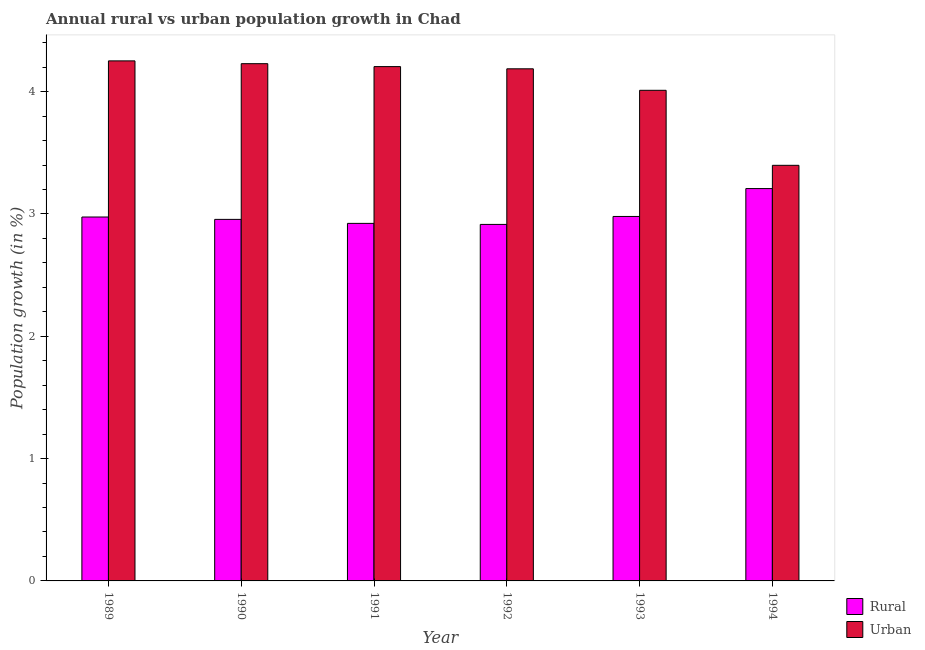How many different coloured bars are there?
Offer a very short reply. 2. Are the number of bars per tick equal to the number of legend labels?
Your answer should be very brief. Yes. Are the number of bars on each tick of the X-axis equal?
Your answer should be very brief. Yes. In how many cases, is the number of bars for a given year not equal to the number of legend labels?
Your response must be concise. 0. What is the rural population growth in 1992?
Your answer should be compact. 2.91. Across all years, what is the maximum urban population growth?
Offer a very short reply. 4.25. Across all years, what is the minimum urban population growth?
Give a very brief answer. 3.4. In which year was the rural population growth maximum?
Offer a terse response. 1994. In which year was the urban population growth minimum?
Provide a succinct answer. 1994. What is the total rural population growth in the graph?
Provide a short and direct response. 17.96. What is the difference between the rural population growth in 1990 and that in 1992?
Your answer should be very brief. 0.04. What is the difference between the rural population growth in 1994 and the urban population growth in 1992?
Make the answer very short. 0.29. What is the average rural population growth per year?
Your answer should be very brief. 2.99. What is the ratio of the urban population growth in 1989 to that in 1990?
Your answer should be very brief. 1.01. Is the rural population growth in 1990 less than that in 1994?
Your answer should be compact. Yes. What is the difference between the highest and the second highest rural population growth?
Make the answer very short. 0.23. What is the difference between the highest and the lowest urban population growth?
Keep it short and to the point. 0.85. Is the sum of the rural population growth in 1991 and 1994 greater than the maximum urban population growth across all years?
Offer a terse response. Yes. What does the 2nd bar from the left in 1994 represents?
Your answer should be very brief. Urban . What does the 1st bar from the right in 1993 represents?
Keep it short and to the point. Urban . How many bars are there?
Provide a short and direct response. 12. How many years are there in the graph?
Make the answer very short. 6. What is the difference between two consecutive major ticks on the Y-axis?
Offer a very short reply. 1. Does the graph contain any zero values?
Offer a very short reply. No. Does the graph contain grids?
Offer a very short reply. No. What is the title of the graph?
Keep it short and to the point. Annual rural vs urban population growth in Chad. Does "IMF concessional" appear as one of the legend labels in the graph?
Your response must be concise. No. What is the label or title of the Y-axis?
Keep it short and to the point. Population growth (in %). What is the Population growth (in %) of Rural in 1989?
Give a very brief answer. 2.98. What is the Population growth (in %) in Urban  in 1989?
Your answer should be compact. 4.25. What is the Population growth (in %) of Rural in 1990?
Make the answer very short. 2.96. What is the Population growth (in %) of Urban  in 1990?
Provide a succinct answer. 4.23. What is the Population growth (in %) of Rural in 1991?
Provide a short and direct response. 2.92. What is the Population growth (in %) in Urban  in 1991?
Give a very brief answer. 4.2. What is the Population growth (in %) in Rural in 1992?
Your answer should be compact. 2.91. What is the Population growth (in %) of Urban  in 1992?
Your response must be concise. 4.19. What is the Population growth (in %) in Rural in 1993?
Your answer should be very brief. 2.98. What is the Population growth (in %) of Urban  in 1993?
Provide a short and direct response. 4.01. What is the Population growth (in %) in Rural in 1994?
Make the answer very short. 3.21. What is the Population growth (in %) in Urban  in 1994?
Your answer should be very brief. 3.4. Across all years, what is the maximum Population growth (in %) in Rural?
Offer a very short reply. 3.21. Across all years, what is the maximum Population growth (in %) of Urban ?
Your answer should be very brief. 4.25. Across all years, what is the minimum Population growth (in %) of Rural?
Offer a terse response. 2.91. Across all years, what is the minimum Population growth (in %) in Urban ?
Your answer should be compact. 3.4. What is the total Population growth (in %) in Rural in the graph?
Your answer should be very brief. 17.96. What is the total Population growth (in %) in Urban  in the graph?
Keep it short and to the point. 24.28. What is the difference between the Population growth (in %) of Rural in 1989 and that in 1990?
Provide a succinct answer. 0.02. What is the difference between the Population growth (in %) in Urban  in 1989 and that in 1990?
Provide a succinct answer. 0.02. What is the difference between the Population growth (in %) of Rural in 1989 and that in 1991?
Offer a terse response. 0.05. What is the difference between the Population growth (in %) in Urban  in 1989 and that in 1991?
Provide a short and direct response. 0.05. What is the difference between the Population growth (in %) of Rural in 1989 and that in 1992?
Offer a very short reply. 0.06. What is the difference between the Population growth (in %) of Urban  in 1989 and that in 1992?
Keep it short and to the point. 0.06. What is the difference between the Population growth (in %) of Rural in 1989 and that in 1993?
Make the answer very short. -0. What is the difference between the Population growth (in %) of Urban  in 1989 and that in 1993?
Offer a terse response. 0.24. What is the difference between the Population growth (in %) in Rural in 1989 and that in 1994?
Keep it short and to the point. -0.23. What is the difference between the Population growth (in %) in Urban  in 1989 and that in 1994?
Give a very brief answer. 0.85. What is the difference between the Population growth (in %) in Rural in 1990 and that in 1991?
Provide a succinct answer. 0.03. What is the difference between the Population growth (in %) of Urban  in 1990 and that in 1991?
Give a very brief answer. 0.02. What is the difference between the Population growth (in %) in Rural in 1990 and that in 1992?
Provide a short and direct response. 0.04. What is the difference between the Population growth (in %) of Urban  in 1990 and that in 1992?
Your response must be concise. 0.04. What is the difference between the Population growth (in %) in Rural in 1990 and that in 1993?
Offer a terse response. -0.02. What is the difference between the Population growth (in %) in Urban  in 1990 and that in 1993?
Offer a very short reply. 0.22. What is the difference between the Population growth (in %) of Rural in 1990 and that in 1994?
Provide a short and direct response. -0.25. What is the difference between the Population growth (in %) in Urban  in 1990 and that in 1994?
Offer a terse response. 0.83. What is the difference between the Population growth (in %) in Rural in 1991 and that in 1992?
Offer a terse response. 0.01. What is the difference between the Population growth (in %) of Urban  in 1991 and that in 1992?
Provide a succinct answer. 0.02. What is the difference between the Population growth (in %) of Rural in 1991 and that in 1993?
Give a very brief answer. -0.06. What is the difference between the Population growth (in %) of Urban  in 1991 and that in 1993?
Your response must be concise. 0.19. What is the difference between the Population growth (in %) of Rural in 1991 and that in 1994?
Your response must be concise. -0.28. What is the difference between the Population growth (in %) of Urban  in 1991 and that in 1994?
Provide a short and direct response. 0.81. What is the difference between the Population growth (in %) in Rural in 1992 and that in 1993?
Provide a succinct answer. -0.07. What is the difference between the Population growth (in %) of Urban  in 1992 and that in 1993?
Offer a very short reply. 0.18. What is the difference between the Population growth (in %) of Rural in 1992 and that in 1994?
Make the answer very short. -0.29. What is the difference between the Population growth (in %) of Urban  in 1992 and that in 1994?
Make the answer very short. 0.79. What is the difference between the Population growth (in %) in Rural in 1993 and that in 1994?
Your response must be concise. -0.23. What is the difference between the Population growth (in %) of Urban  in 1993 and that in 1994?
Keep it short and to the point. 0.61. What is the difference between the Population growth (in %) in Rural in 1989 and the Population growth (in %) in Urban  in 1990?
Keep it short and to the point. -1.25. What is the difference between the Population growth (in %) in Rural in 1989 and the Population growth (in %) in Urban  in 1991?
Keep it short and to the point. -1.23. What is the difference between the Population growth (in %) of Rural in 1989 and the Population growth (in %) of Urban  in 1992?
Your response must be concise. -1.21. What is the difference between the Population growth (in %) in Rural in 1989 and the Population growth (in %) in Urban  in 1993?
Offer a very short reply. -1.04. What is the difference between the Population growth (in %) in Rural in 1989 and the Population growth (in %) in Urban  in 1994?
Your answer should be compact. -0.42. What is the difference between the Population growth (in %) of Rural in 1990 and the Population growth (in %) of Urban  in 1991?
Offer a terse response. -1.25. What is the difference between the Population growth (in %) in Rural in 1990 and the Population growth (in %) in Urban  in 1992?
Provide a short and direct response. -1.23. What is the difference between the Population growth (in %) of Rural in 1990 and the Population growth (in %) of Urban  in 1993?
Offer a terse response. -1.06. What is the difference between the Population growth (in %) of Rural in 1990 and the Population growth (in %) of Urban  in 1994?
Provide a short and direct response. -0.44. What is the difference between the Population growth (in %) of Rural in 1991 and the Population growth (in %) of Urban  in 1992?
Give a very brief answer. -1.26. What is the difference between the Population growth (in %) of Rural in 1991 and the Population growth (in %) of Urban  in 1993?
Provide a succinct answer. -1.09. What is the difference between the Population growth (in %) of Rural in 1991 and the Population growth (in %) of Urban  in 1994?
Keep it short and to the point. -0.47. What is the difference between the Population growth (in %) of Rural in 1992 and the Population growth (in %) of Urban  in 1993?
Ensure brevity in your answer.  -1.1. What is the difference between the Population growth (in %) in Rural in 1992 and the Population growth (in %) in Urban  in 1994?
Ensure brevity in your answer.  -0.48. What is the difference between the Population growth (in %) of Rural in 1993 and the Population growth (in %) of Urban  in 1994?
Provide a short and direct response. -0.42. What is the average Population growth (in %) in Rural per year?
Give a very brief answer. 2.99. What is the average Population growth (in %) of Urban  per year?
Offer a terse response. 4.05. In the year 1989, what is the difference between the Population growth (in %) in Rural and Population growth (in %) in Urban ?
Offer a very short reply. -1.28. In the year 1990, what is the difference between the Population growth (in %) of Rural and Population growth (in %) of Urban ?
Provide a succinct answer. -1.27. In the year 1991, what is the difference between the Population growth (in %) of Rural and Population growth (in %) of Urban ?
Offer a very short reply. -1.28. In the year 1992, what is the difference between the Population growth (in %) of Rural and Population growth (in %) of Urban ?
Your answer should be very brief. -1.27. In the year 1993, what is the difference between the Population growth (in %) of Rural and Population growth (in %) of Urban ?
Give a very brief answer. -1.03. In the year 1994, what is the difference between the Population growth (in %) in Rural and Population growth (in %) in Urban ?
Your answer should be compact. -0.19. What is the ratio of the Population growth (in %) of Rural in 1989 to that in 1990?
Offer a terse response. 1.01. What is the ratio of the Population growth (in %) of Urban  in 1989 to that in 1990?
Make the answer very short. 1.01. What is the ratio of the Population growth (in %) in Rural in 1989 to that in 1991?
Offer a very short reply. 1.02. What is the ratio of the Population growth (in %) of Urban  in 1989 to that in 1991?
Your answer should be compact. 1.01. What is the ratio of the Population growth (in %) of Rural in 1989 to that in 1992?
Ensure brevity in your answer.  1.02. What is the ratio of the Population growth (in %) of Urban  in 1989 to that in 1992?
Give a very brief answer. 1.02. What is the ratio of the Population growth (in %) of Urban  in 1989 to that in 1993?
Provide a short and direct response. 1.06. What is the ratio of the Population growth (in %) of Rural in 1989 to that in 1994?
Give a very brief answer. 0.93. What is the ratio of the Population growth (in %) of Urban  in 1989 to that in 1994?
Your answer should be compact. 1.25. What is the ratio of the Population growth (in %) of Rural in 1990 to that in 1991?
Offer a terse response. 1.01. What is the ratio of the Population growth (in %) in Rural in 1990 to that in 1992?
Ensure brevity in your answer.  1.01. What is the ratio of the Population growth (in %) in Rural in 1990 to that in 1993?
Offer a terse response. 0.99. What is the ratio of the Population growth (in %) in Urban  in 1990 to that in 1993?
Your response must be concise. 1.05. What is the ratio of the Population growth (in %) in Rural in 1990 to that in 1994?
Provide a succinct answer. 0.92. What is the ratio of the Population growth (in %) of Urban  in 1990 to that in 1994?
Keep it short and to the point. 1.24. What is the ratio of the Population growth (in %) in Rural in 1991 to that in 1992?
Keep it short and to the point. 1. What is the ratio of the Population growth (in %) in Urban  in 1991 to that in 1992?
Give a very brief answer. 1. What is the ratio of the Population growth (in %) of Urban  in 1991 to that in 1993?
Provide a short and direct response. 1.05. What is the ratio of the Population growth (in %) in Rural in 1991 to that in 1994?
Ensure brevity in your answer.  0.91. What is the ratio of the Population growth (in %) in Urban  in 1991 to that in 1994?
Offer a terse response. 1.24. What is the ratio of the Population growth (in %) in Rural in 1992 to that in 1993?
Keep it short and to the point. 0.98. What is the ratio of the Population growth (in %) of Urban  in 1992 to that in 1993?
Your response must be concise. 1.04. What is the ratio of the Population growth (in %) in Rural in 1992 to that in 1994?
Give a very brief answer. 0.91. What is the ratio of the Population growth (in %) of Urban  in 1992 to that in 1994?
Offer a terse response. 1.23. What is the ratio of the Population growth (in %) in Rural in 1993 to that in 1994?
Give a very brief answer. 0.93. What is the ratio of the Population growth (in %) in Urban  in 1993 to that in 1994?
Make the answer very short. 1.18. What is the difference between the highest and the second highest Population growth (in %) of Rural?
Your answer should be compact. 0.23. What is the difference between the highest and the second highest Population growth (in %) in Urban ?
Your answer should be very brief. 0.02. What is the difference between the highest and the lowest Population growth (in %) of Rural?
Your response must be concise. 0.29. What is the difference between the highest and the lowest Population growth (in %) in Urban ?
Offer a terse response. 0.85. 